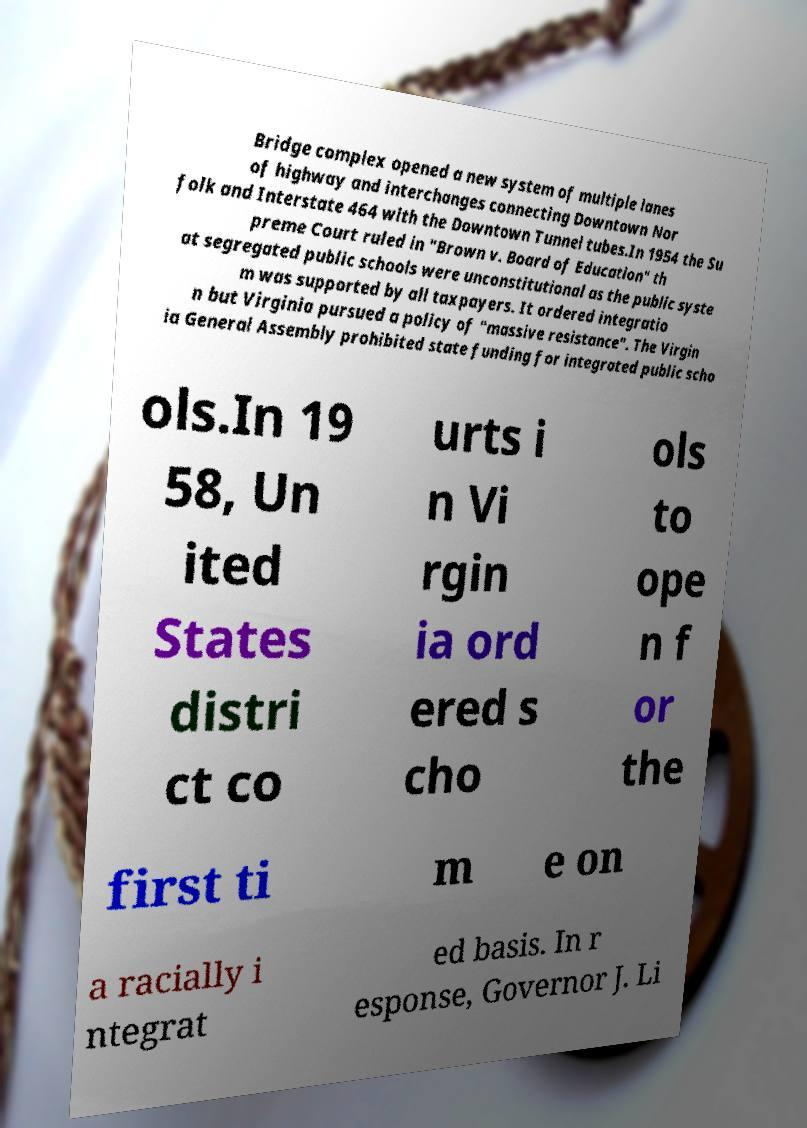Can you accurately transcribe the text from the provided image for me? Bridge complex opened a new system of multiple lanes of highway and interchanges connecting Downtown Nor folk and Interstate 464 with the Downtown Tunnel tubes.In 1954 the Su preme Court ruled in "Brown v. Board of Education" th at segregated public schools were unconstitutional as the public syste m was supported by all taxpayers. It ordered integratio n but Virginia pursued a policy of "massive resistance". The Virgin ia General Assembly prohibited state funding for integrated public scho ols.In 19 58, Un ited States distri ct co urts i n Vi rgin ia ord ered s cho ols to ope n f or the first ti m e on a racially i ntegrat ed basis. In r esponse, Governor J. Li 